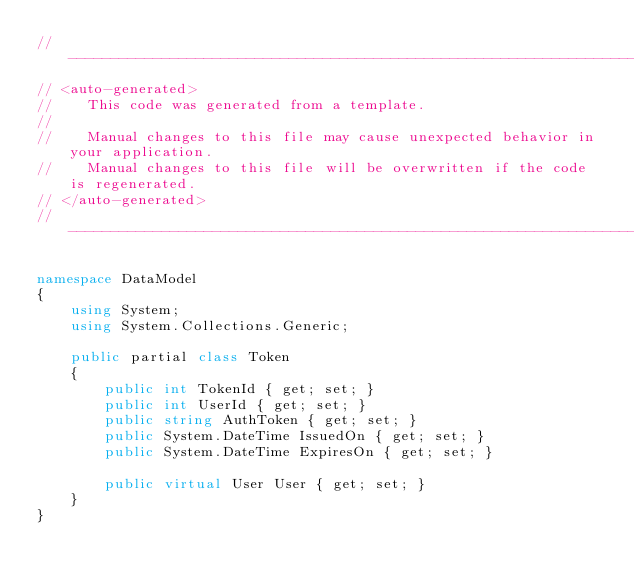Convert code to text. <code><loc_0><loc_0><loc_500><loc_500><_C#_>//------------------------------------------------------------------------------
// <auto-generated>
//    This code was generated from a template.
//
//    Manual changes to this file may cause unexpected behavior in your application.
//    Manual changes to this file will be overwritten if the code is regenerated.
// </auto-generated>
//------------------------------------------------------------------------------

namespace DataModel
{
    using System;
    using System.Collections.Generic;
    
    public partial class Token
    {
        public int TokenId { get; set; }
        public int UserId { get; set; }
        public string AuthToken { get; set; }
        public System.DateTime IssuedOn { get; set; }
        public System.DateTime ExpiresOn { get; set; }
    
        public virtual User User { get; set; }
    }
}
</code> 